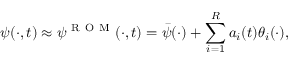<formula> <loc_0><loc_0><loc_500><loc_500>\psi ( \cdot , t ) \approx \psi ^ { R O M } ( \cdot , t ) = \bar { \psi } ( \cdot ) + \sum _ { i = 1 } ^ { R } a _ { i } ( t ) \theta _ { i } ( \cdot ) ,</formula> 